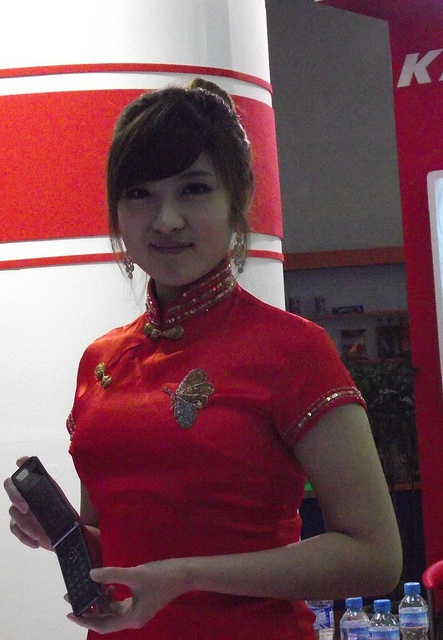Describe the objects in this image and their specific colors. I can see people in white, maroon, black, gray, and brown tones, cell phone in white, black, gray, and purple tones, bottle in white, gray, darkgray, and blue tones, bottle in white, gray, and blue tones, and bottle in white, gray, blue, and darkgray tones in this image. 